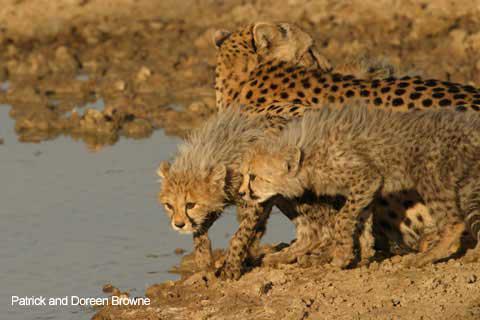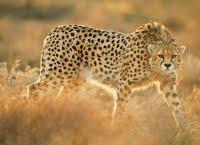The first image is the image on the left, the second image is the image on the right. Evaluate the accuracy of this statement regarding the images: "Not more than one cheetah in any of the pictures". Is it true? Answer yes or no. No. The first image is the image on the left, the second image is the image on the right. Evaluate the accuracy of this statement regarding the images: "There is a single cheetah running in the left image.". Is it true? Answer yes or no. No. 